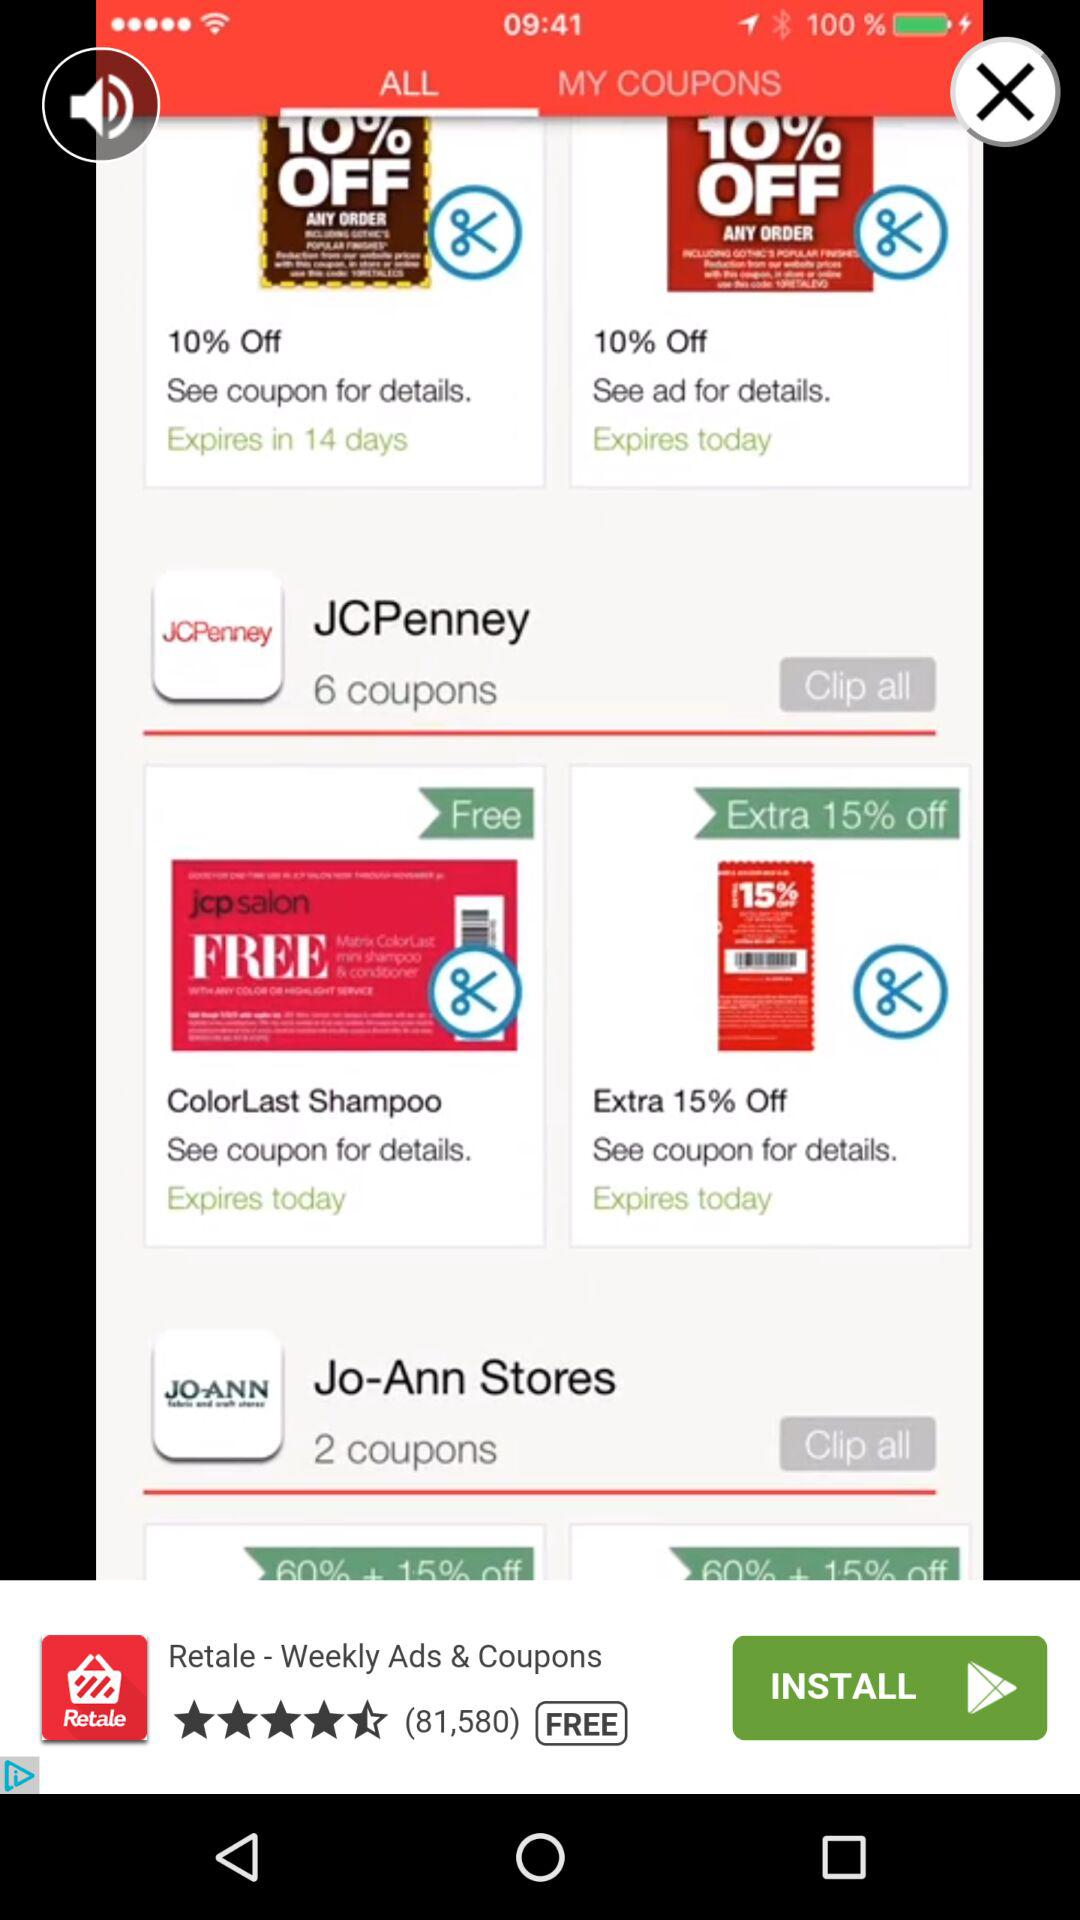How many "Jo-Ann Stores" coupons are there? There are 2 "Jo-Ann Stores" coupons. 